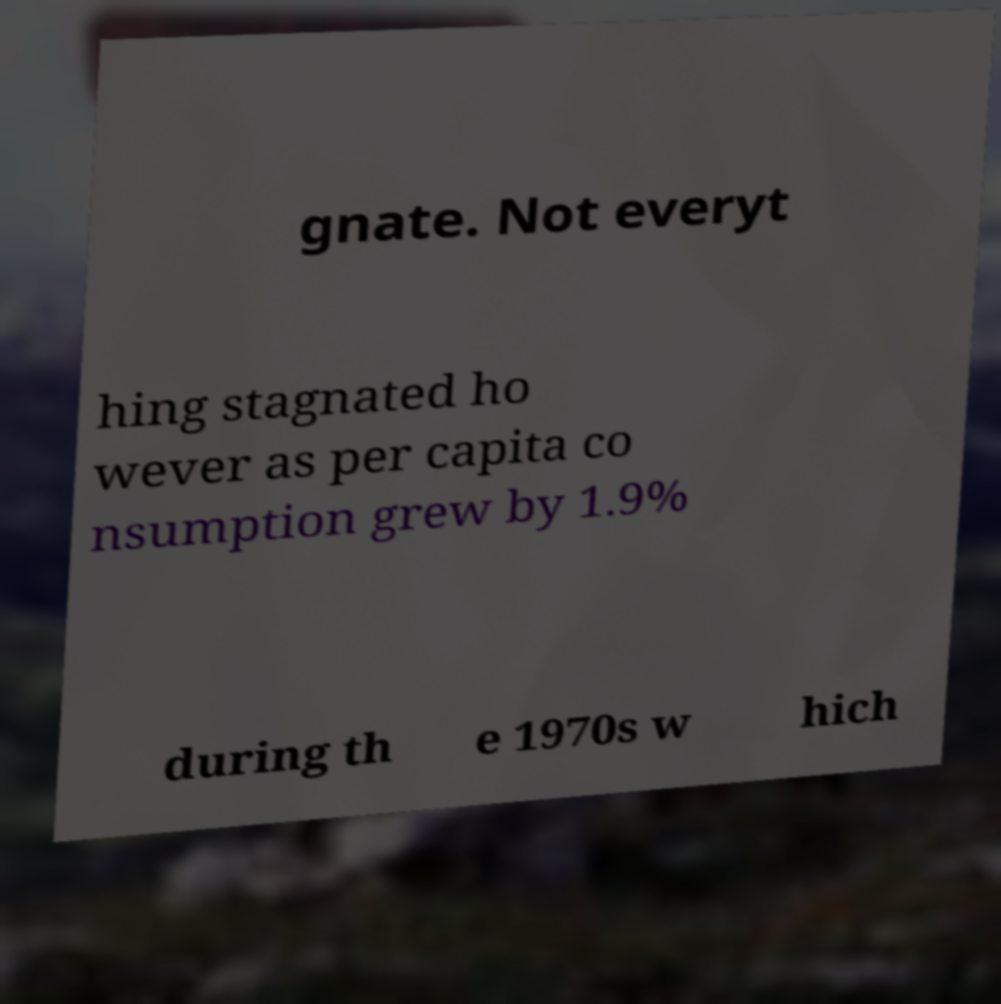There's text embedded in this image that I need extracted. Can you transcribe it verbatim? gnate. Not everyt hing stagnated ho wever as per capita co nsumption grew by 1.9% during th e 1970s w hich 